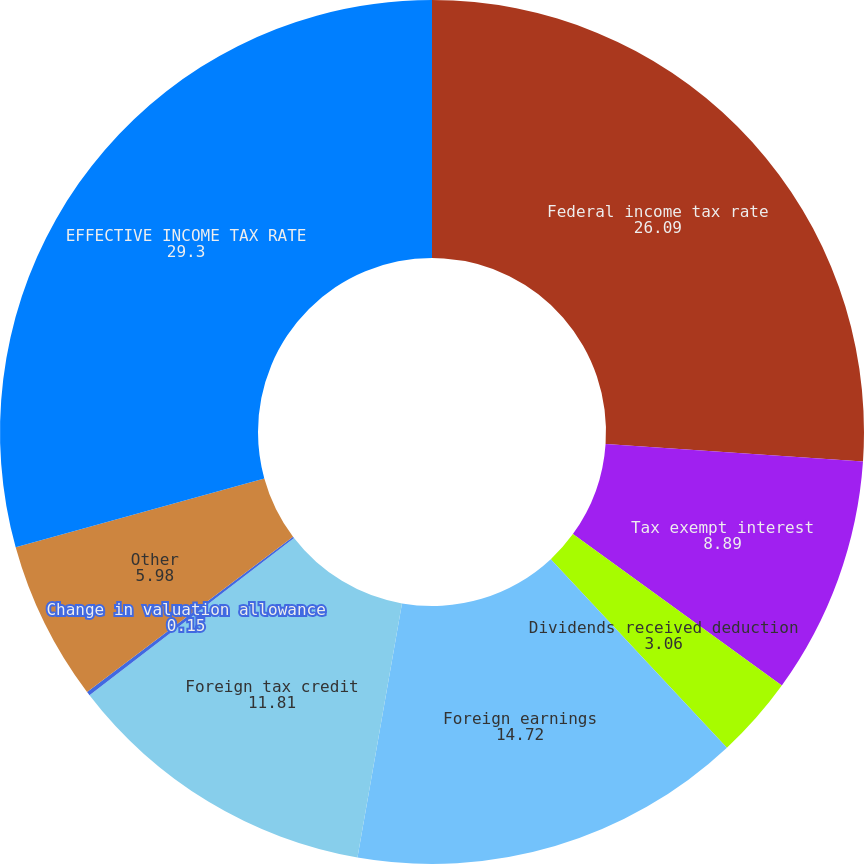Convert chart to OTSL. <chart><loc_0><loc_0><loc_500><loc_500><pie_chart><fcel>Federal income tax rate<fcel>Tax exempt interest<fcel>Dividends received deduction<fcel>Foreign earnings<fcel>Foreign tax credit<fcel>Change in valuation allowance<fcel>Other<fcel>EFFECTIVE INCOME TAX RATE<nl><fcel>26.09%<fcel>8.89%<fcel>3.06%<fcel>14.72%<fcel>11.81%<fcel>0.15%<fcel>5.98%<fcel>29.3%<nl></chart> 